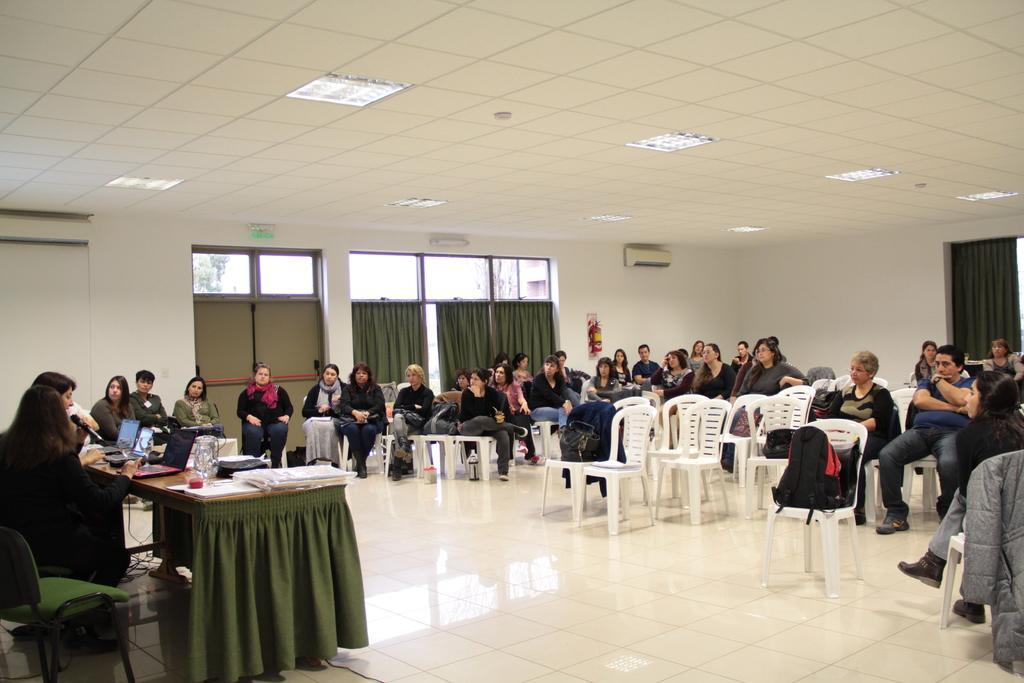Describe this image in one or two sentences. In this picture there are many people sitting in the chairs in a room. There is a table in front of which some of the people were sitting. On the table, there laptop and some jars, papers were present. In the background, there are some curtains and a windows here. We can observe a wall. 